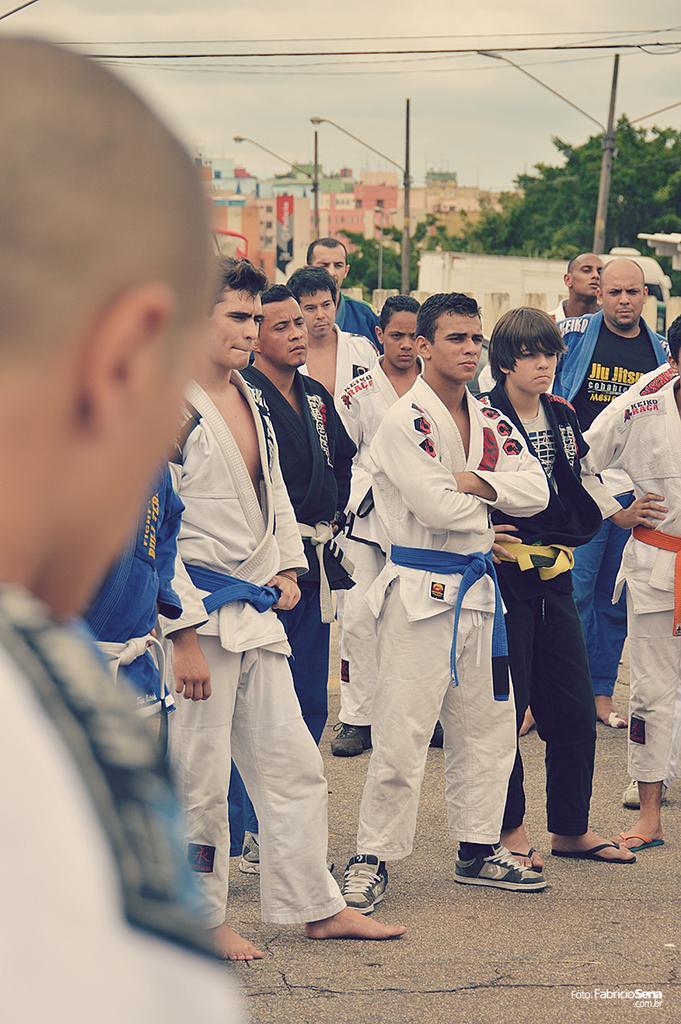Could you give a brief overview of what you see in this image? In this picture we can see a group of people standing on the ground, poles, buildings, trees, wires and in the background we can see the sky. 